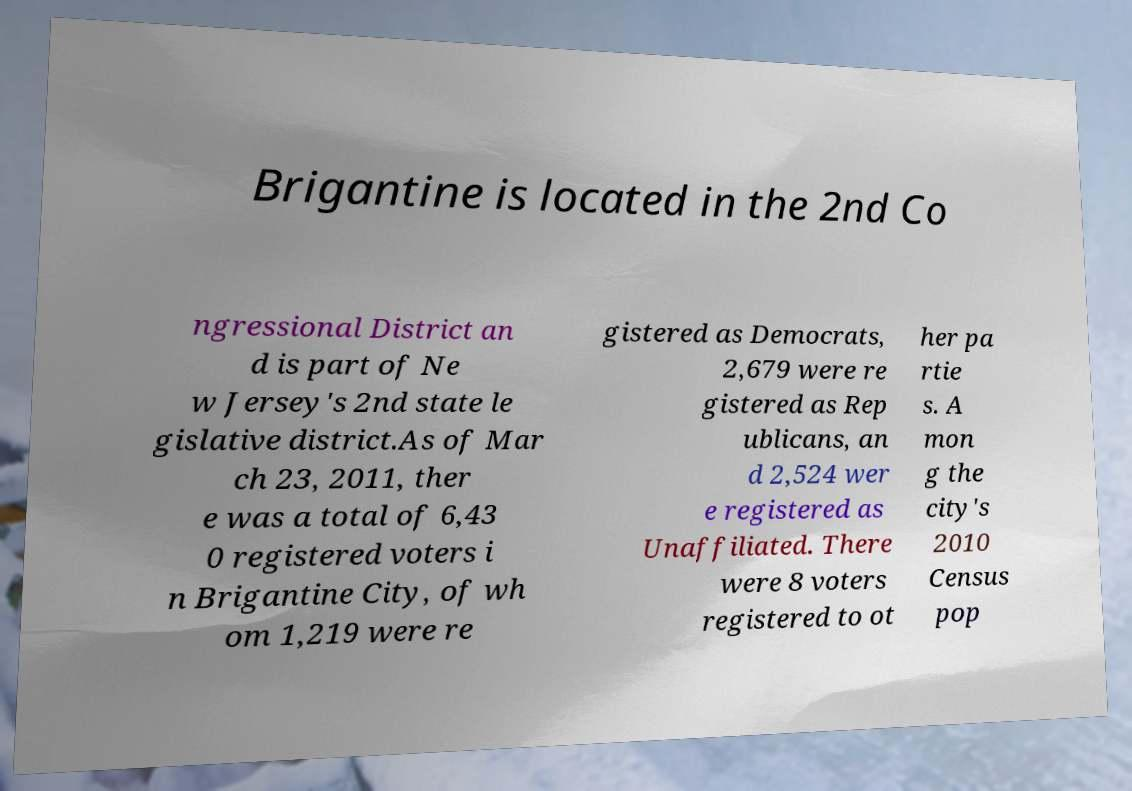I need the written content from this picture converted into text. Can you do that? Brigantine is located in the 2nd Co ngressional District an d is part of Ne w Jersey's 2nd state le gislative district.As of Mar ch 23, 2011, ther e was a total of 6,43 0 registered voters i n Brigantine City, of wh om 1,219 were re gistered as Democrats, 2,679 were re gistered as Rep ublicans, an d 2,524 wer e registered as Unaffiliated. There were 8 voters registered to ot her pa rtie s. A mon g the city's 2010 Census pop 